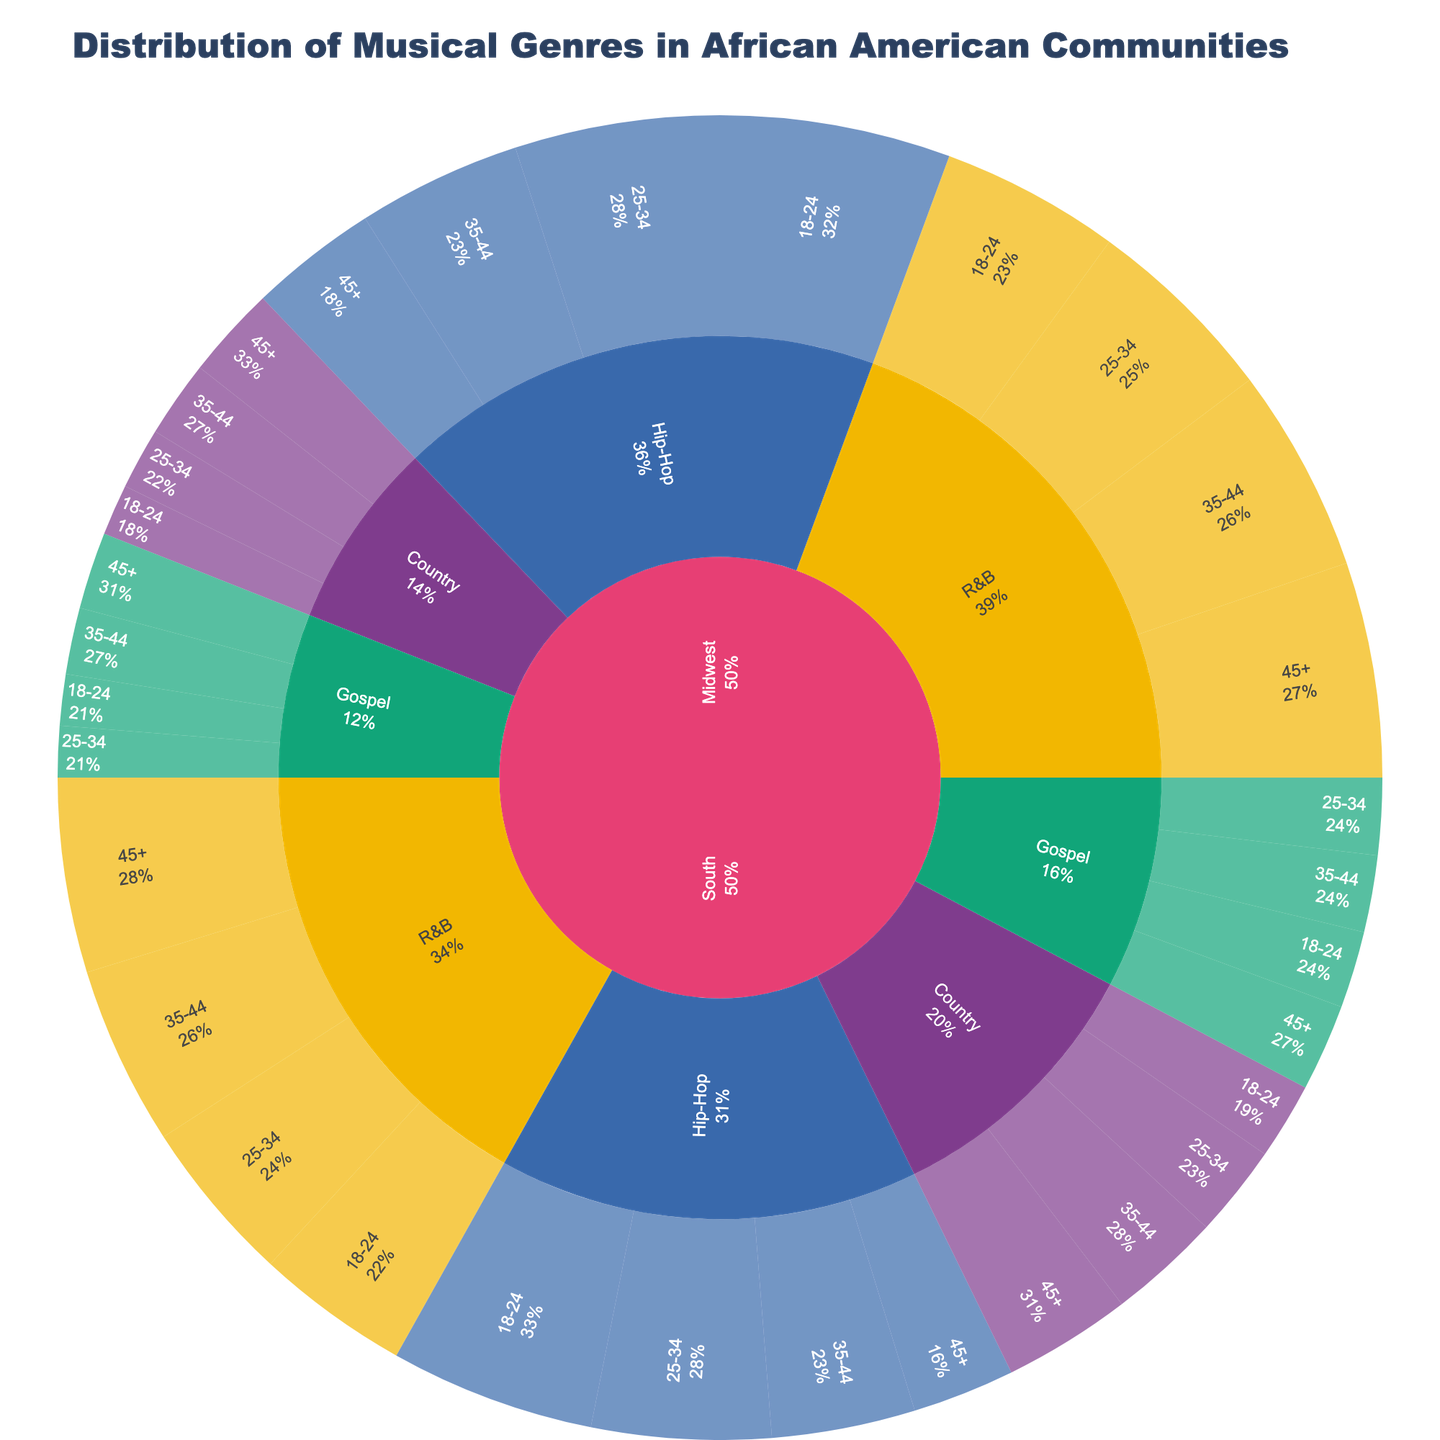What is the title of the plot? The title is usually displayed prominently at the top of the figure. In this case, it is stated in the code provided.
Answer: Distribution of Musical Genres in African American Communities Which genre has the highest percentage in the South region for the 18-24 age group? Look at the segment for the South region, then find the 18-24 age group and identify the genre with the largest section.
Answer: Hip-Hop Among the 45+ age group in the Midwest, which genre is the least preferred? Examine the Midwest region, then locate the 45+ age group and find the genre with the smallest section.
Answer: Gospel What is the combined percentage of Hip-Hop listeners in the Midwest across all age groups? Find the percentages for Hip-Hop in the Midwest for all age groups (18-24, 25-34, 35-44, and 45+), then sum them up.
Answer: 142 Is Country music more popular in the South or the Midwest for the 35-44 age group? Compare the percentages of Country music for the 35-44 age group in both the South and Midwest regions.
Answer: South How does the popularity of R&B in the South for the 18-24 age group compare to the 45+ age group? Look at the R&B percentages for the 18-24 and 45+ age groups in the South and discuss the difference.
Answer: 18-24: 30, 45+: 38 What percentage of the South region's 35-44 age group listens to Gospel music? Navigate to the South region, then find the 35-44 age group and check the section for Gospel music.
Answer: 15 In terms of preferences, which age group shows the highest percentage for Hip-Hop in the entire dataset? Compare the percentages of Hip-Hop for all age groups in both regions and find the one with the highest value.
Answer: Midwest, 18-24 What's the difference in percentage points for Country music listeners between the South and Midwest regions in the 45+ age group? Find the percentages for Country in the South and Midwest for the 45+ age group, then calculate the difference.
Answer: 25 - 18 = 7 What is the overall trend for the Gospel music genre across different age groups in both regions? Observe the pattern of percentages for Gospel music across all age groups in both regions and describe the trend.
Answer: Relatively stable with a slight increase in older age groups 